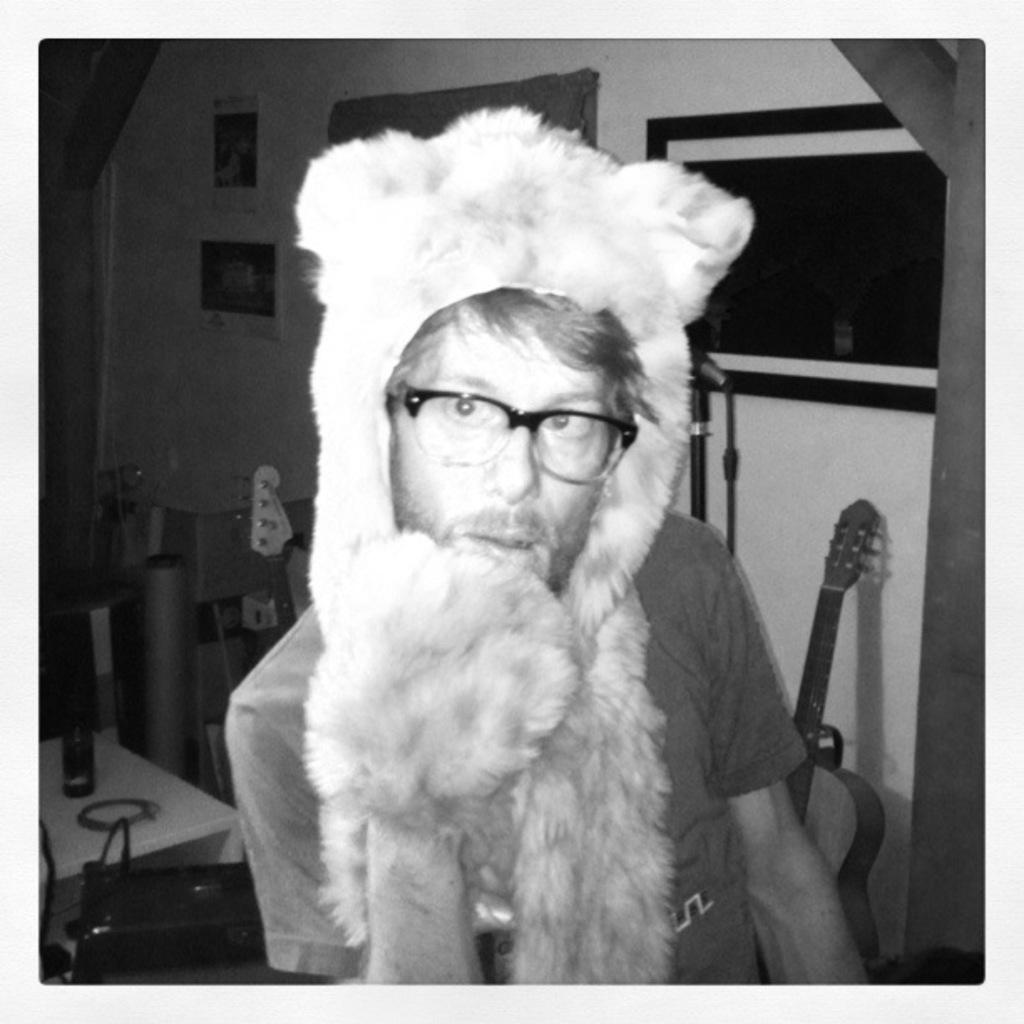What is the man in the image wearing on his face? The man is wearing a mask. What type of eyewear is the man wearing in the image? The man is wearing spectacles. What can be seen in the background of the image? There is a bottle, a bag on a table, a wall with frames, and a guitar in the background of the image. What type of snake can be seen slithering on the guitar in the image? There is no snake present in the image; it only features a man wearing a mask and spectacles, as well as various objects in the background. 